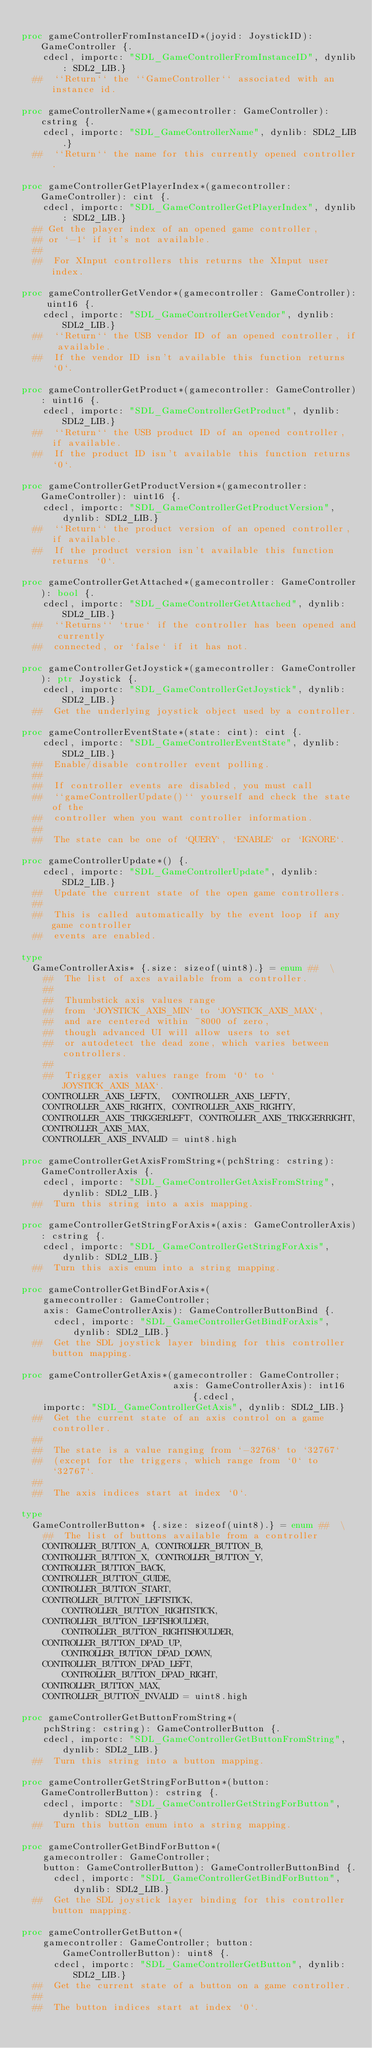Convert code to text. <code><loc_0><loc_0><loc_500><loc_500><_Nim_>
proc gameControllerFromInstanceID*(joyid: JoystickID): GameController {.
    cdecl, importc: "SDL_GameControllerFromInstanceID", dynlib: SDL2_LIB.}
  ##  ``Return`` the ``GameController`` associated with an instance id.

proc gameControllerName*(gamecontroller: GameController): cstring {.
    cdecl, importc: "SDL_GameControllerName", dynlib: SDL2_LIB.}
  ##  ``Return`` the name for this currently opened controller.

proc gameControllerGetPlayerIndex*(gamecontroller: GameController): cint {.
    cdecl, importc: "SDL_GameControllerGetPlayerIndex", dynlib: SDL2_LIB.}
  ## Get the player index of an opened game controller,
  ## or `-1` if it's not available.
  ##
  ##  For XInput controllers this returns the XInput user index.

proc gameControllerGetVendor*(gamecontroller: GameController): uint16 {.
    cdecl, importc: "SDL_GameControllerGetVendor", dynlib: SDL2_LIB.}
  ##  ``Return`` the USB vendor ID of an opened controller, if available.
  ##  If the vendor ID isn't available this function returns `0`.

proc gameControllerGetProduct*(gamecontroller: GameController): uint16 {.
    cdecl, importc: "SDL_GameControllerGetProduct", dynlib: SDL2_LIB.}
  ##  ``Return`` the USB product ID of an opened controller, if available.
  ##  If the product ID isn't available this function returns `0`.

proc gameControllerGetProductVersion*(gamecontroller: GameController): uint16 {.
    cdecl, importc: "SDL_GameControllerGetProductVersion", dynlib: SDL2_LIB.}
  ##  ``Return`` the product version of an opened controller, if available.
  ##  If the product version isn't available this function returns `0`.

proc gameControllerGetAttached*(gamecontroller: GameController): bool {.
    cdecl, importc: "SDL_GameControllerGetAttached", dynlib: SDL2_LIB.}
  ##  ``Returns`` `true` if the controller has been opened and currently
  ##  connected, or `false` if it has not.

proc gameControllerGetJoystick*(gamecontroller: GameController): ptr Joystick {.
    cdecl, importc: "SDL_GameControllerGetJoystick", dynlib: SDL2_LIB.}
  ##  Get the underlying joystick object used by a controller.

proc gameControllerEventState*(state: cint): cint {.
    cdecl, importc: "SDL_GameControllerEventState", dynlib: SDL2_LIB.}
  ##  Enable/disable controller event polling.
  ##
  ##  If controller events are disabled, you must call
  ##  ``gameControllerUpdate()`` yourself and check the state of the
  ##  controller when you want controller information.
  ##
  ##  The state can be one of `QUERY`, `ENABLE` or `IGNORE`.

proc gameControllerUpdate*() {.
    cdecl, importc: "SDL_GameControllerUpdate", dynlib: SDL2_LIB.}
  ##  Update the current state of the open game controllers.
  ##
  ##  This is called automatically by the event loop if any game controller
  ##  events are enabled.

type
  GameControllerAxis* {.size: sizeof(uint8).} = enum ##  \
    ##  The list of axes available from a controller.
    ##
    ##  Thumbstick axis values range
    ##  from `JOYSTICK_AXIS_MIN` to `JOYSTICK_AXIS_MAX`,
    ##  and are centered within ~8000 of zero,
    ##  though advanced UI will allow users to set
    ##  or autodetect the dead zone, which varies between controllers.
    ##
    ##  Trigger axis values range from `0` to `JOYSTICK_AXIS_MAX`.
    CONTROLLER_AXIS_LEFTX,  CONTROLLER_AXIS_LEFTY,
    CONTROLLER_AXIS_RIGHTX, CONTROLLER_AXIS_RIGHTY,
    CONTROLLER_AXIS_TRIGGERLEFT, CONTROLLER_AXIS_TRIGGERRIGHT,
    CONTROLLER_AXIS_MAX,
    CONTROLLER_AXIS_INVALID = uint8.high

proc gameControllerGetAxisFromString*(pchString: cstring): GameControllerAxis {.
    cdecl, importc: "SDL_GameControllerGetAxisFromString", dynlib: SDL2_LIB.}
  ##  Turn this string into a axis mapping.

proc gameControllerGetStringForAxis*(axis: GameControllerAxis): cstring {.
    cdecl, importc: "SDL_GameControllerGetStringForAxis", dynlib: SDL2_LIB.}
  ##  Turn this axis enum into a string mapping.

proc gameControllerGetBindForAxis*(
    gamecontroller: GameController;
    axis: GameControllerAxis): GameControllerButtonBind {.
      cdecl, importc: "SDL_GameControllerGetBindForAxis", dynlib: SDL2_LIB.}
  ##  Get the SDL joystick layer binding for this controller button mapping.

proc gameControllerGetAxis*(gamecontroller: GameController; 
                            axis: GameControllerAxis): int16 {.cdecl, 
    importc: "SDL_GameControllerGetAxis", dynlib: SDL2_LIB.}
  ##  Get the current state of an axis control on a game controller.
  ##
  ##  The state is a value ranging from `-32768` to `32767`
  ##  (except for the triggers, which range from `0` to `32767`.
  ##
  ##  The axis indices start at index `0`.

type
  GameControllerButton* {.size: sizeof(uint8).} = enum ##  \
    ##  The list of buttons available from a controller
    CONTROLLER_BUTTON_A, CONTROLLER_BUTTON_B,
    CONTROLLER_BUTTON_X, CONTROLLER_BUTTON_Y,
    CONTROLLER_BUTTON_BACK,
    CONTROLLER_BUTTON_GUIDE,
    CONTROLLER_BUTTON_START, 
    CONTROLLER_BUTTON_LEFTSTICK,    CONTROLLER_BUTTON_RIGHTSTICK,
    CONTROLLER_BUTTON_LEFTSHOULDER, CONTROLLER_BUTTON_RIGHTSHOULDER,
    CONTROLLER_BUTTON_DPAD_UP,      CONTROLLER_BUTTON_DPAD_DOWN,
    CONTROLLER_BUTTON_DPAD_LEFT,    CONTROLLER_BUTTON_DPAD_RIGHT,
    CONTROLLER_BUTTON_MAX,
    CONTROLLER_BUTTON_INVALID = uint8.high

proc gameControllerGetButtonFromString*(
    pchString: cstring): GameControllerButton {.
    cdecl, importc: "SDL_GameControllerGetButtonFromString", dynlib: SDL2_LIB.}
  ##  Turn this string into a button mapping.

proc gameControllerGetStringForButton*(button: GameControllerButton): cstring {.
    cdecl, importc: "SDL_GameControllerGetStringForButton", dynlib: SDL2_LIB.}
  ##  Turn this button enum into a string mapping.

proc gameControllerGetBindForButton*(
    gamecontroller: GameController;
    button: GameControllerButton): GameControllerButtonBind {.
      cdecl, importc: "SDL_GameControllerGetBindForButton", dynlib: SDL2_LIB.}
  ##  Get the SDL joystick layer binding for this controller button mapping.

proc gameControllerGetButton*(
    gamecontroller: GameController; button: GameControllerButton): uint8 {.
      cdecl, importc: "SDL_GameControllerGetButton", dynlib: SDL2_LIB.}
  ##  Get the current state of a button on a game controller.
  ##
  ##  The button indices start at index `0`.
</code> 